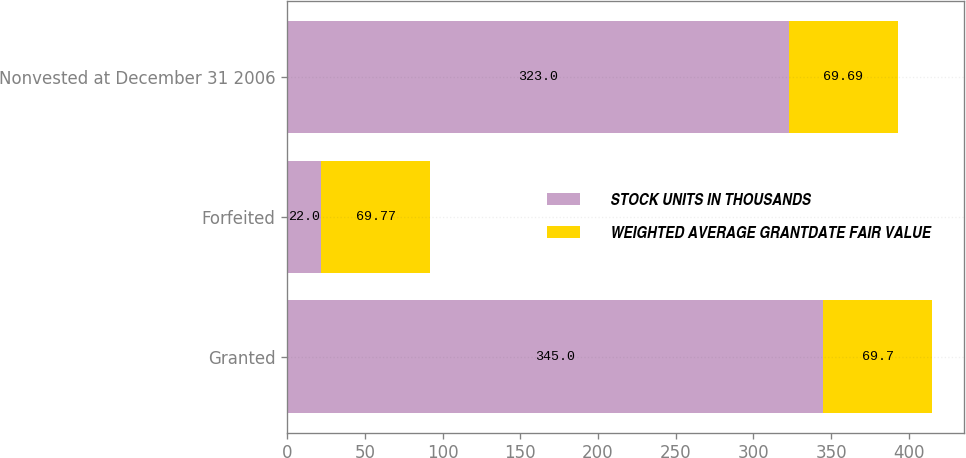Convert chart. <chart><loc_0><loc_0><loc_500><loc_500><stacked_bar_chart><ecel><fcel>Granted<fcel>Forfeited<fcel>Nonvested at December 31 2006<nl><fcel>STOCK UNITS IN THOUSANDS<fcel>345<fcel>22<fcel>323<nl><fcel>WEIGHTED AVERAGE GRANTDATE FAIR VALUE<fcel>69.7<fcel>69.77<fcel>69.69<nl></chart> 